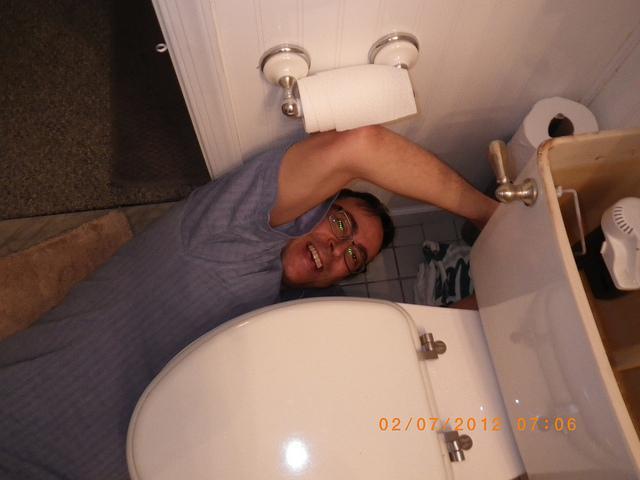How many toilets are in the photo?
Give a very brief answer. 1. 